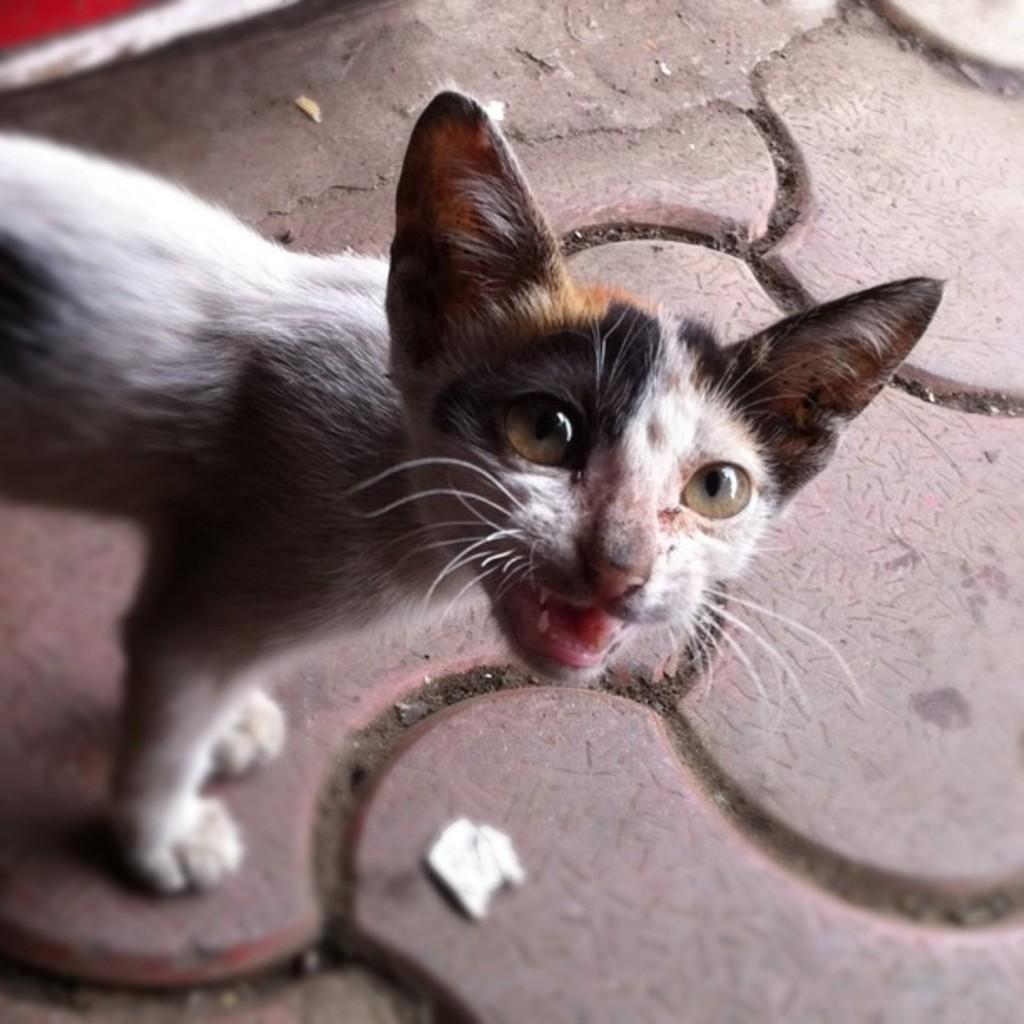What type of animal is in the image? There is a cat in the image. What is the primary surface visible in the image? There is ground visible in the image. What type of cast can be seen on the cat's leg in the image? There is no cast visible on the cat's leg in the image, as the cat appears to be healthy and uninjured. 